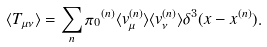<formula> <loc_0><loc_0><loc_500><loc_500>\langle T _ { \mu \nu } \rangle = \sum _ { n } { \pi _ { 0 } } ^ { ( n ) } \langle v _ { \mu } ^ { ( n ) } \rangle \langle v _ { \nu } ^ { ( n ) } \rangle \delta ^ { 3 } ( { x - x ^ { ( n ) } } ) .</formula> 